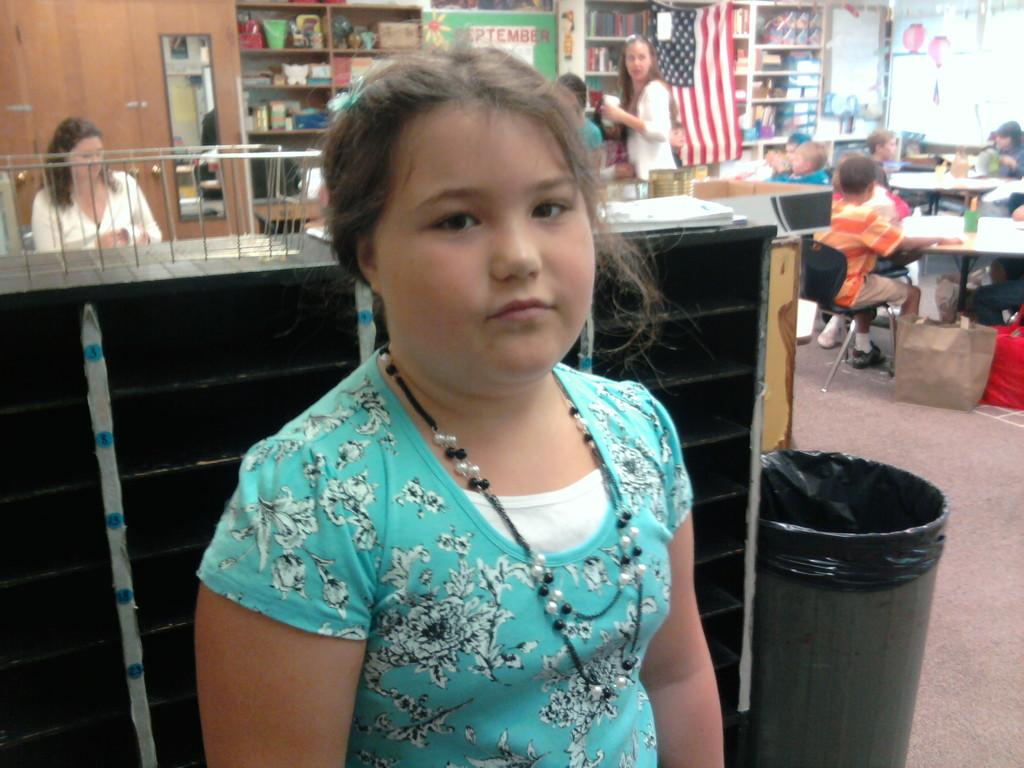Who is the main subject in the image? There is a girl in the image. What is the girl doing in the image? The girl is standing and posing for the camera. Can you describe the background of the image? There are people in the background of the image. What type of camp can be seen in the background of the image? There is no camp present in the image; it only features the girl posing and people in the background. 